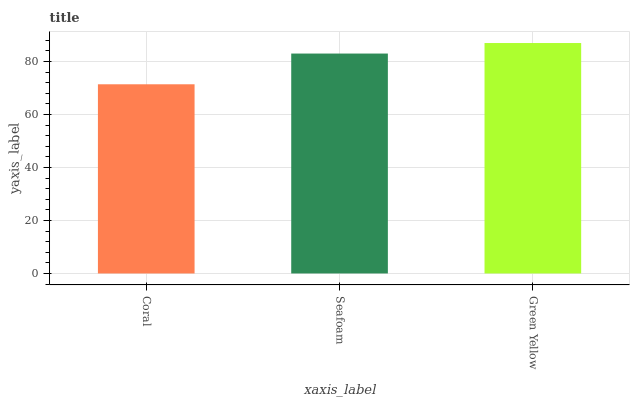Is Coral the minimum?
Answer yes or no. Yes. Is Green Yellow the maximum?
Answer yes or no. Yes. Is Seafoam the minimum?
Answer yes or no. No. Is Seafoam the maximum?
Answer yes or no. No. Is Seafoam greater than Coral?
Answer yes or no. Yes. Is Coral less than Seafoam?
Answer yes or no. Yes. Is Coral greater than Seafoam?
Answer yes or no. No. Is Seafoam less than Coral?
Answer yes or no. No. Is Seafoam the high median?
Answer yes or no. Yes. Is Seafoam the low median?
Answer yes or no. Yes. Is Coral the high median?
Answer yes or no. No. Is Green Yellow the low median?
Answer yes or no. No. 